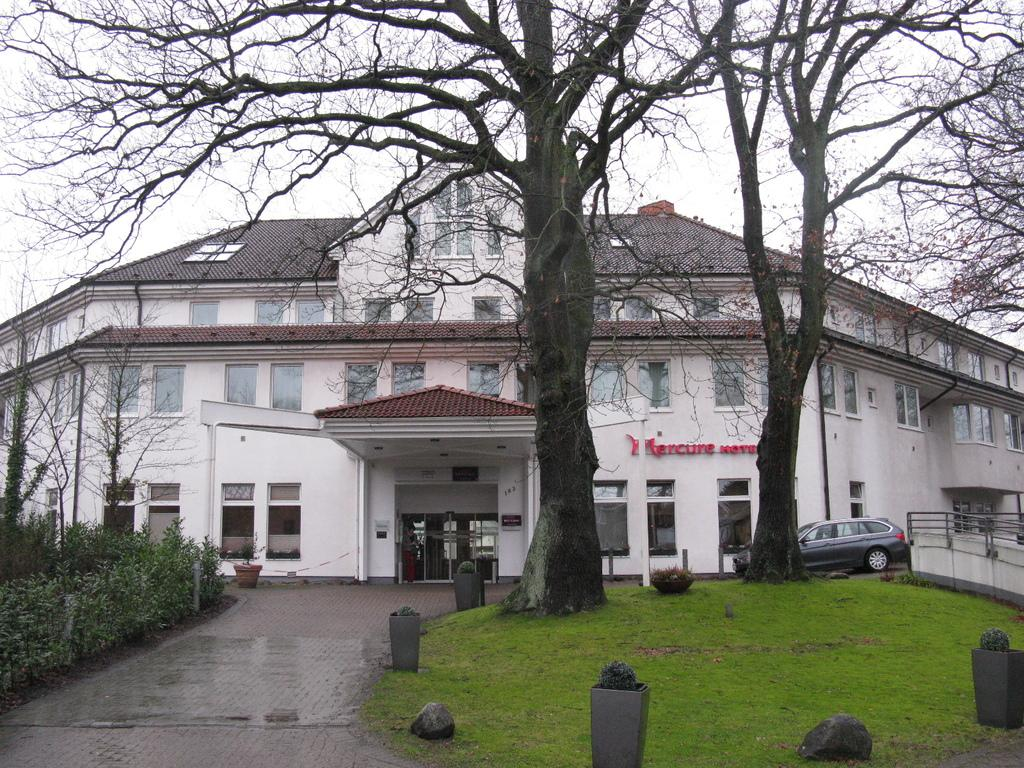What type of structure is visible in the image? There is a building in the image. What is parked in front of the building? There is a car parked in front of the building. What type of vegetation can be seen in the image? There are trees, potted plants, grass, and plants visible in the image. What type of ground cover is present in the image? There are stones in the image. What is the boundary material in the image? There is a fence in the image. What part of the natural environment is visible in the image? The sky is visible in the image. What type of board is being used to butter the lumber in the image? There is no board, butter, or lumber present in the image. 